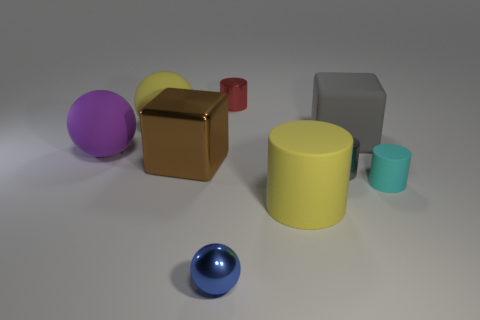Subtract 1 spheres. How many spheres are left? 2 Subtract all gray cylinders. How many cylinders are left? 3 Subtract all gray cylinders. How many cylinders are left? 3 Add 1 small red things. How many objects exist? 10 Subtract all yellow cylinders. Subtract all purple balls. How many cylinders are left? 3 Subtract all blocks. How many objects are left? 7 Subtract all yellow rubber cylinders. Subtract all big yellow metallic spheres. How many objects are left? 8 Add 3 brown objects. How many brown objects are left? 4 Add 3 small green things. How many small green things exist? 3 Subtract 1 gray cylinders. How many objects are left? 8 